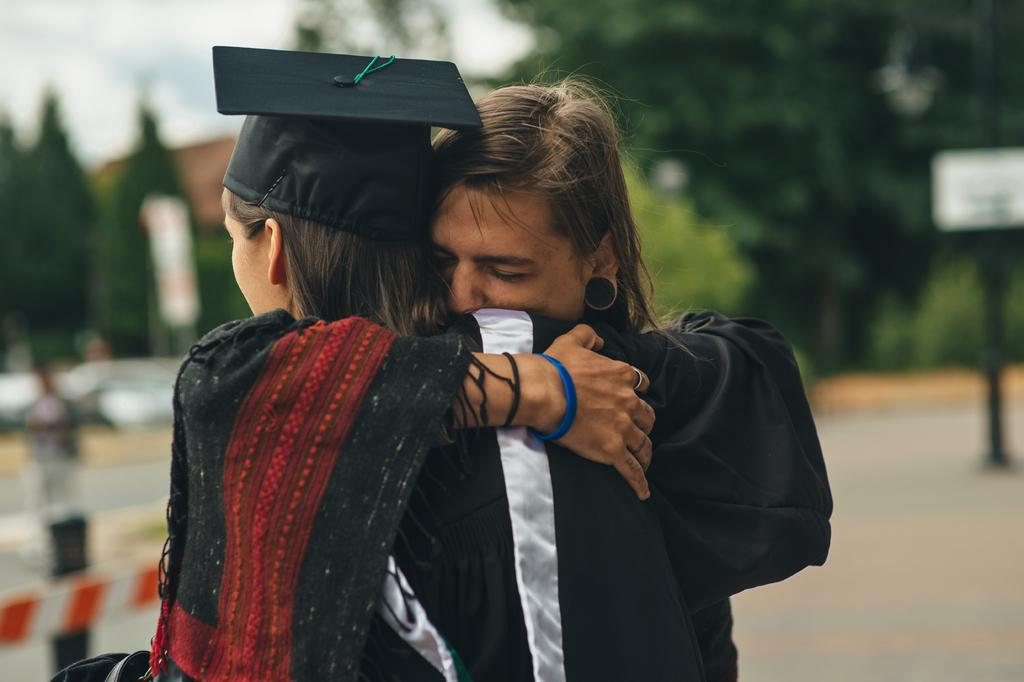How many people are in the image? There are two persons in the image. What are the two persons doing in the image? The two persons are hugging each other. What are the two persons wearing in the image? The two persons are wearing graduation costumes. What can be seen in the background of the image? There are trees in the background of the image. What type of hammer can be seen in the hands of one of the persons in the image? There is no hammer present in the image; the two persons are wearing graduation costumes and hugging each other. Can you see any rats in the image? There are no rats present in the image; the background features trees. 